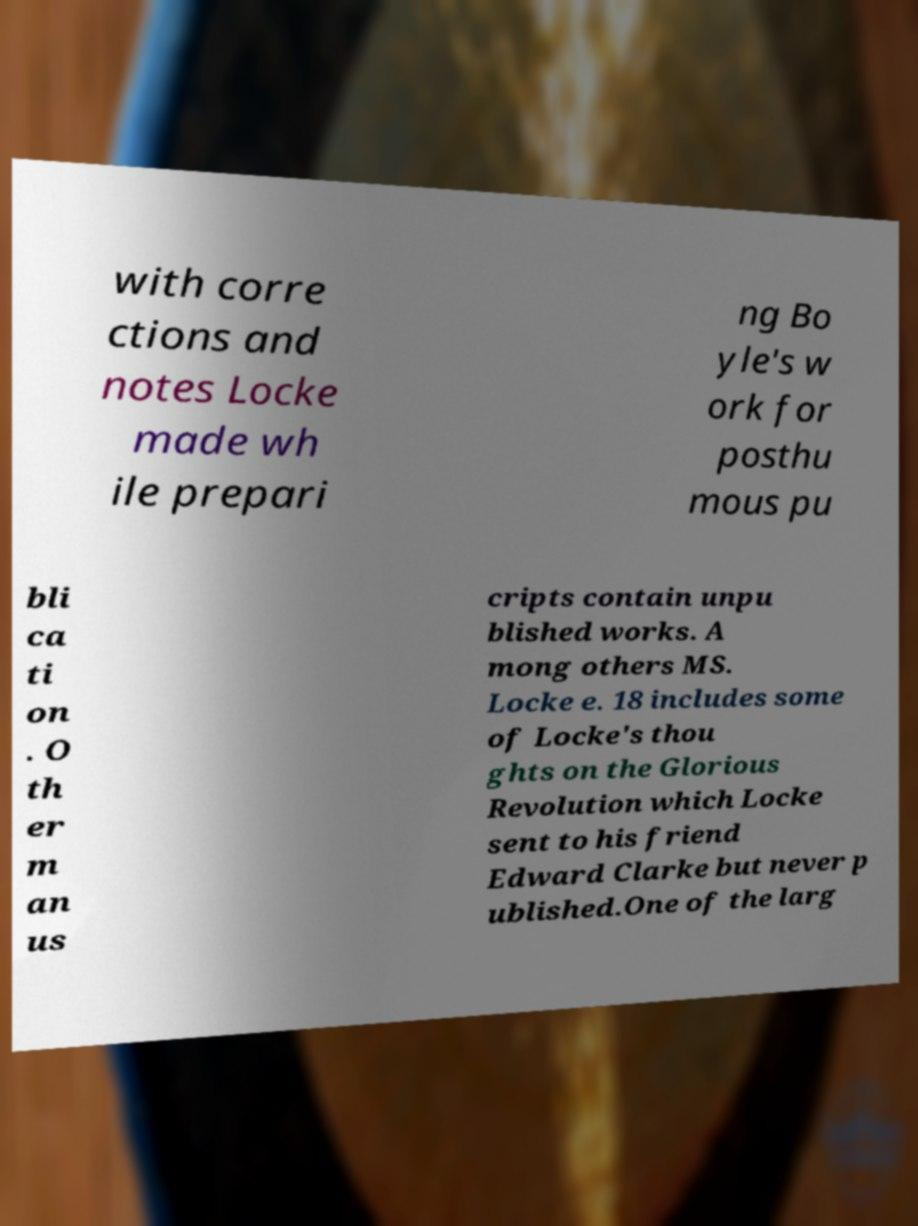What messages or text are displayed in this image? I need them in a readable, typed format. with corre ctions and notes Locke made wh ile prepari ng Bo yle's w ork for posthu mous pu bli ca ti on . O th er m an us cripts contain unpu blished works. A mong others MS. Locke e. 18 includes some of Locke's thou ghts on the Glorious Revolution which Locke sent to his friend Edward Clarke but never p ublished.One of the larg 